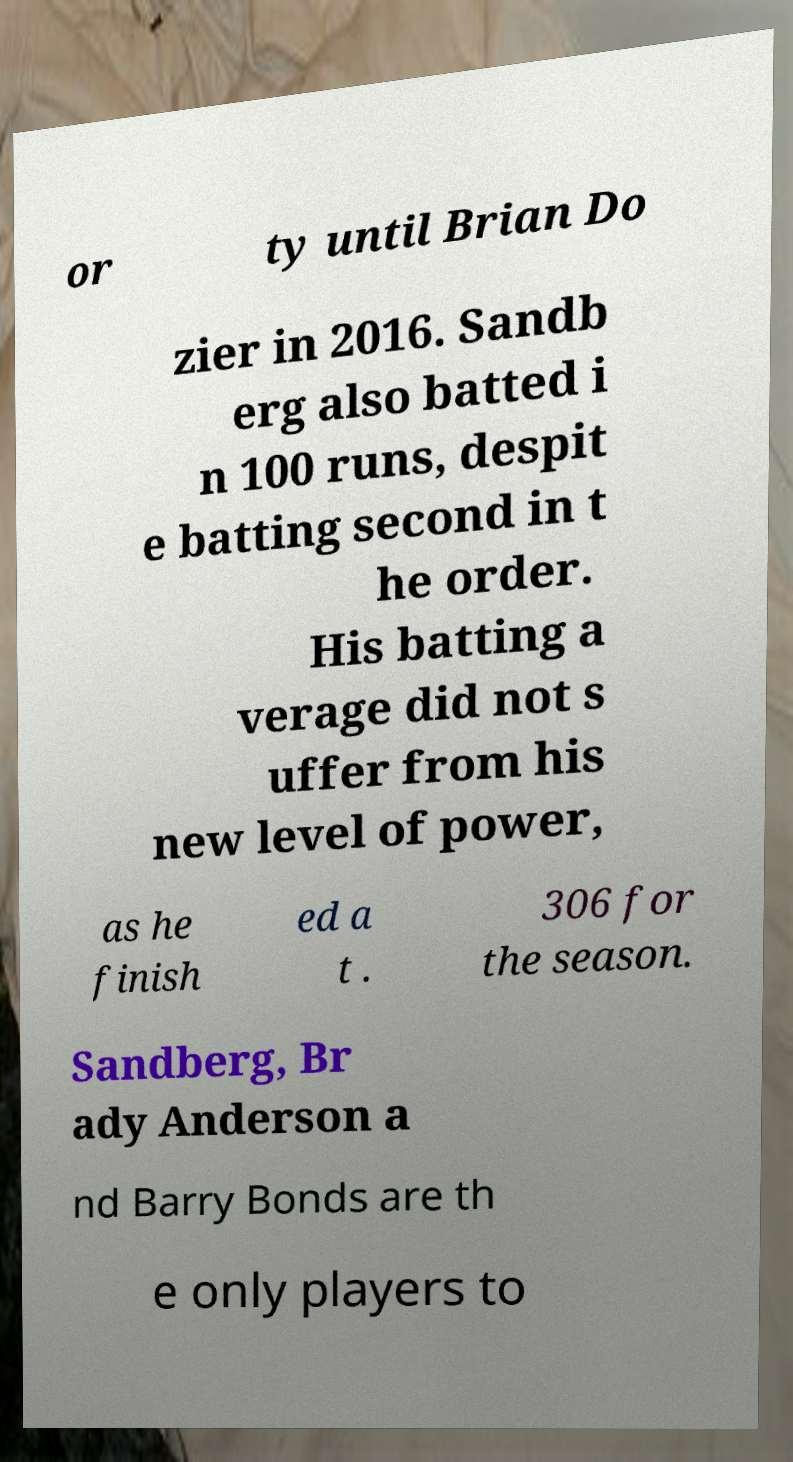Please identify and transcribe the text found in this image. or ty until Brian Do zier in 2016. Sandb erg also batted i n 100 runs, despit e batting second in t he order. His batting a verage did not s uffer from his new level of power, as he finish ed a t . 306 for the season. Sandberg, Br ady Anderson a nd Barry Bonds are th e only players to 